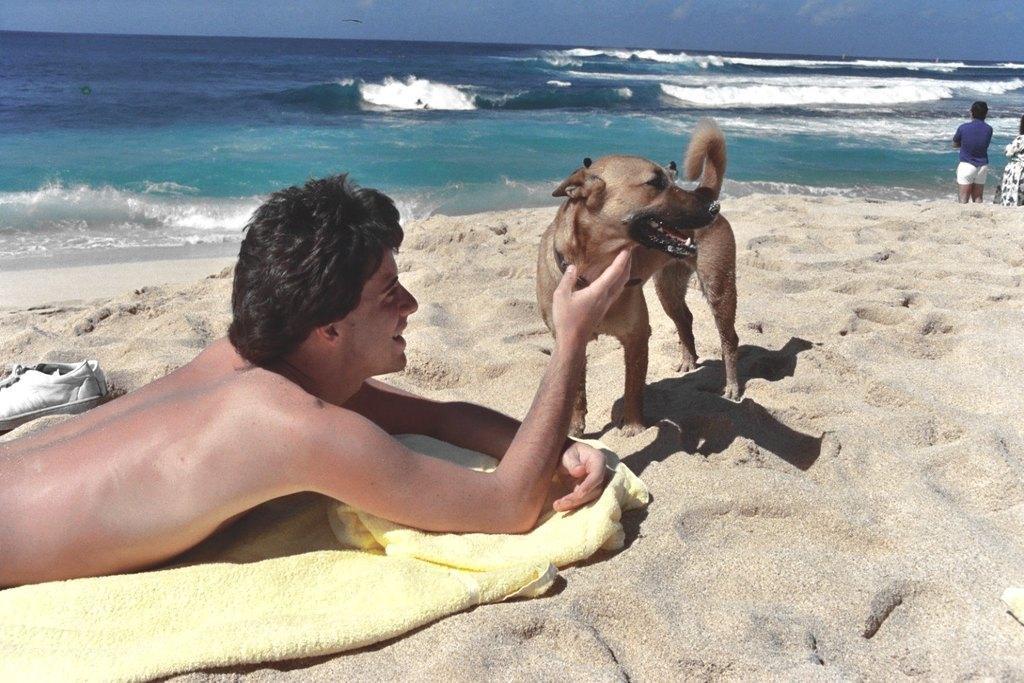How would you summarize this image in a sentence or two? in this picture we can see a man lying on the sand near sea shore ,and at down there is a cloth, and in front of him there is dog, and at opposite there is water, and at above there is sky. 